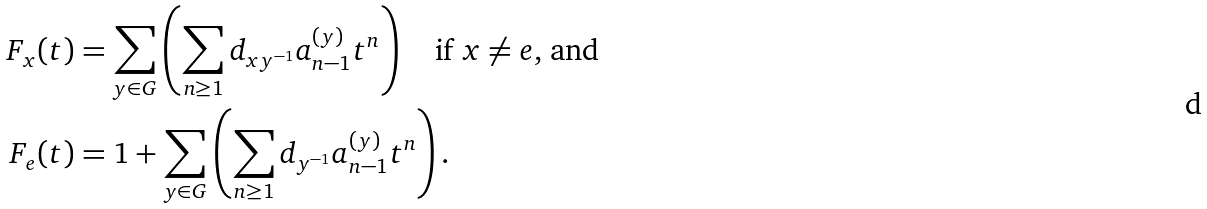<formula> <loc_0><loc_0><loc_500><loc_500>F _ { x } ( t ) & = \sum _ { y \in G } \left ( \sum _ { n \geq 1 } d _ { x y ^ { - 1 } } a _ { n - 1 } ^ { ( y ) } t ^ { n } \right ) \quad \text {if $x\ne e$, and} \\ F _ { e } ( t ) & = 1 + \sum _ { y \in G } \left ( \sum _ { n \geq 1 } d _ { y ^ { - 1 } } a _ { n - 1 } ^ { ( y ) } t ^ { n } \right ) .</formula> 